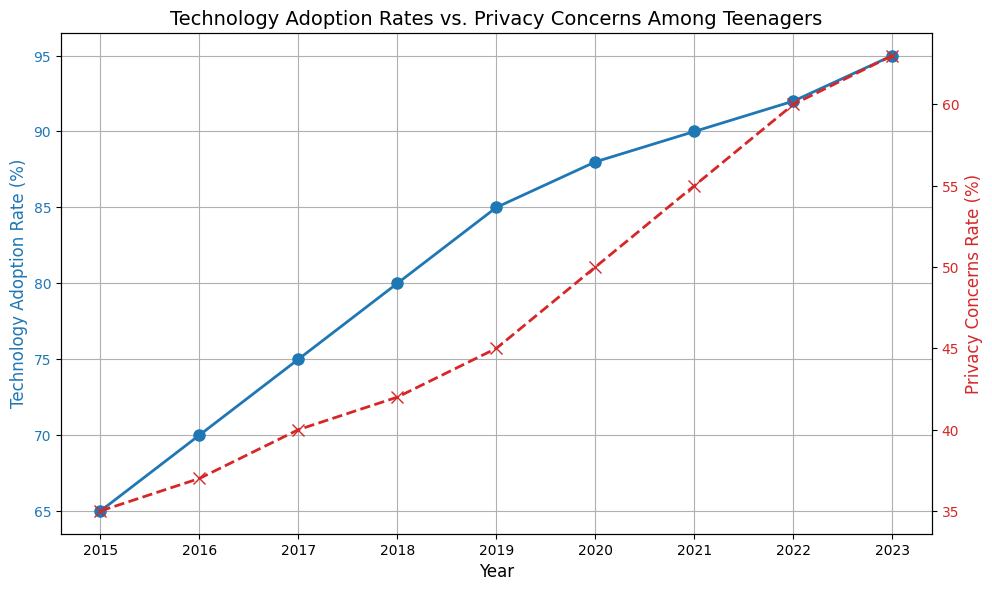What's the difference between the Technology Adoption Rate and Privacy Concerns Rate in 2021? In 2021, the Technology Adoption Rate is 90%, and the Privacy Concerns Rate is 55%. Their difference is 90% - 55% = 35%.
Answer: 35% Which year shows the largest increase in Privacy Concerns Rate? To find the largest increase, we need to compare the year-over-year differences in Privacy Concerns Rate. Reviewing the data, the largest increase is between 2016 and 2017, where the rate jumps from 37% to 40%, an increase of 3%.
Answer: 2017 What trend can be observed regarding the Technology Adoption Rate over the years? Observing the blue line (Technology Adoption Rate) from 2015 to 2023, there is a consistent upward trend, indicating a steady increase in the Technology Adoption Rate over these years.
Answer: Steady increase In which year do the increases in Technology Adoption and Privacy Concerns Rates both exceed 5% compared to the previous year? Reviewing the data year by year, in 2020, the Technology Adoption Rate increased from 85% to 88% (3%), and the Privacy Concerns Rate increased from 45% to 50% (5%). Therefore, there is no year where both increases exceed 5%.
Answer: None What's the average Technology Adoption Rate from 2015 to 2023? To find the average, add the Technology Adoption Rates for all years (65+70+75+80+85+88+90+92+95) and divide by the number of years (9). The sum is 740, so the average is 740/9 ≈ 82.22.
Answer: 82.22 In 2018, by how much is the Technology Adoption Rate higher than the Privacy Concerns Rate? In 2018, the Technology Adoption Rate is 80%, and the Privacy Concerns Rate is 42%. The difference is 80% - 42% = 38%.
Answer: 38% Which year has the lowest Privacy Concerns Rate, and what is its value? The year with the lowest Privacy Concerns Rate is 2015, with a value of 35%.
Answer: 2015, 35% Compare the Privacy Concerns Rate in 2019 to the Technology Adoption Rate in 2019. Which is higher? In 2019, the Technology Adoption Rate is 85%, and the Privacy Concerns Rate is 45%. The Technology Adoption Rate is higher.
Answer: Technology Adoption Rate How much did the Privacy Concerns Rate increase from 2020 to 2023? The Privacy Concerns Rate in 2020 is 50%, and in 2023, it's 63%. The increase is 63% - 50% = 13%.
Answer: 13% 